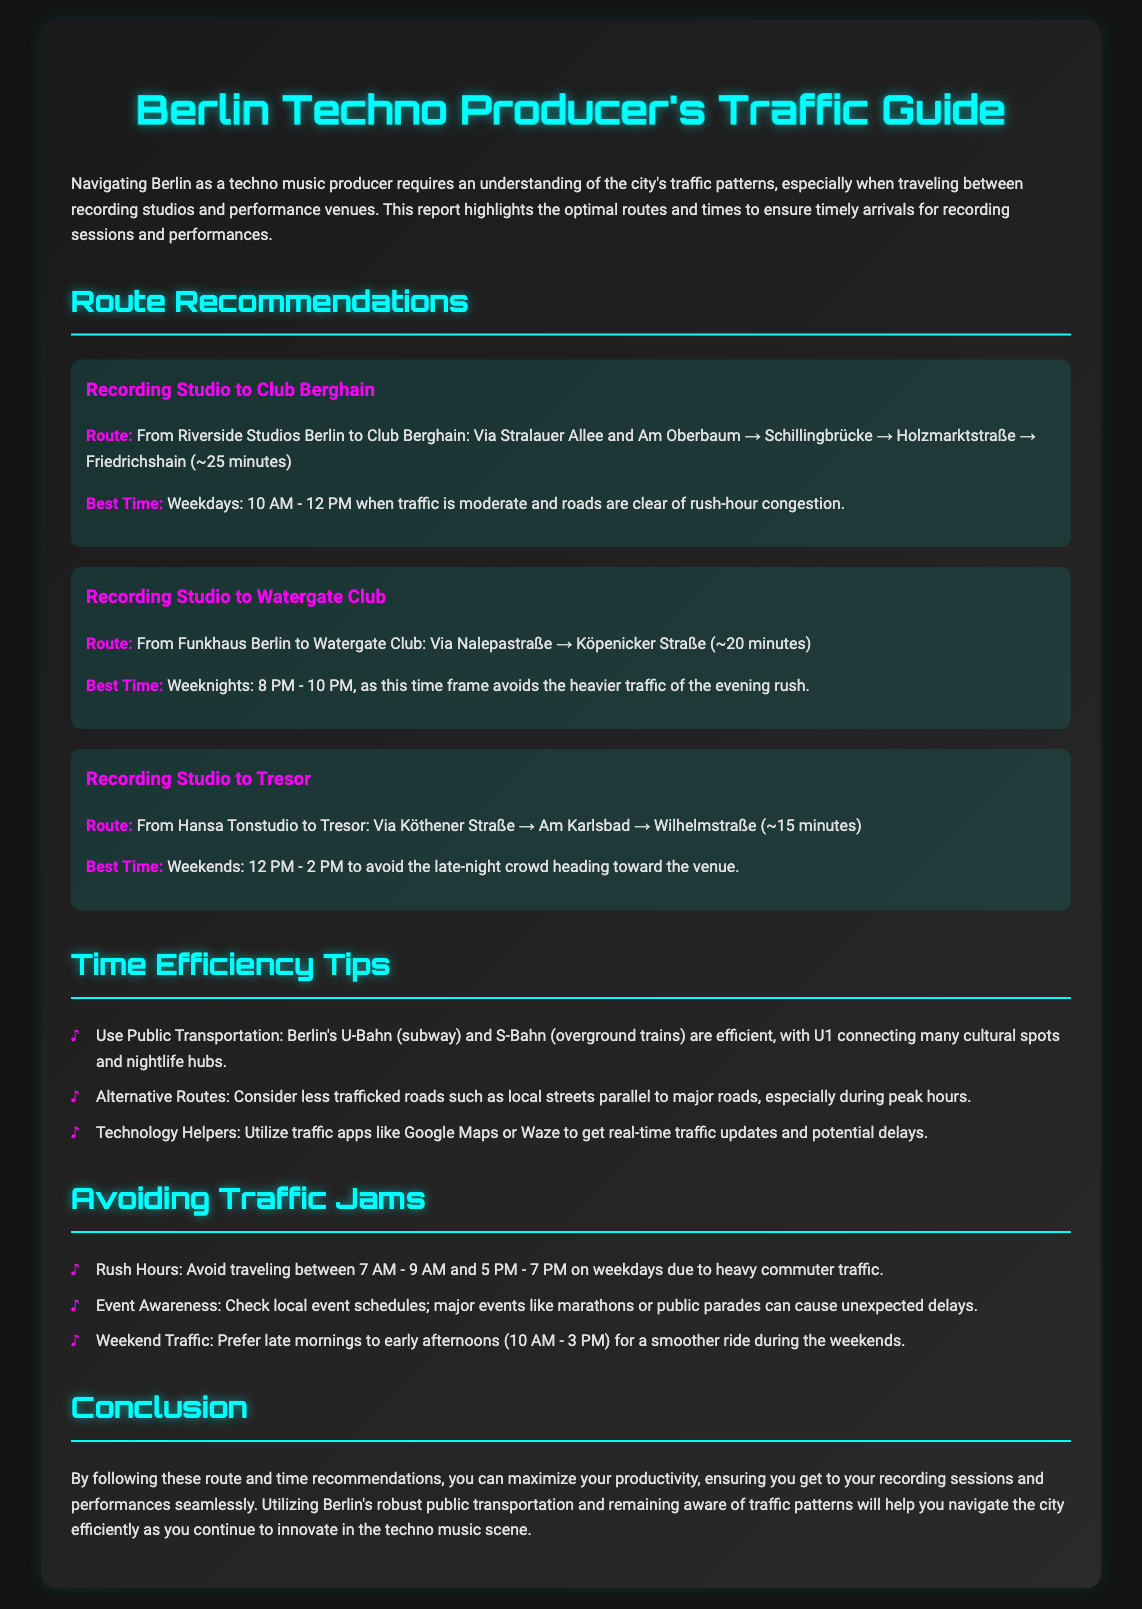What is the best time to travel from Riverside Studios to Club Berghain? The document states that the best time is weekdays from 10 AM to 12 PM when traffic is moderate.
Answer: Weekdays: 10 AM - 12 PM What route is recommended from Funkhaus Berlin to Watergate Club? The route recommended is via Nalepastraße and Köpenicker Straße.
Answer: Via Nalepastraße → Köpenicker Straße How long does it take to get from Hansa Tonstudio to Tresor? The document specifies that the travel time is approximately 15 minutes.
Answer: ~15 minutes What is a time efficiency tip mentioned in the document? The document mentions using public transportation, such as U-Bahn and S-Bahn, as an efficiency tip.
Answer: Use Public Transportation During which hours should you avoid traveling on weekdays? The document specifies avoiding weekdays between 7 AM to 9 AM and 5 PM to 7 PM due to heavy commuter traffic.
Answer: 7 AM - 9 AM and 5 PM - 7 PM What is the route from Riverside Studios to Club Berghain? The document outlines the route as Stralauer Allee and Am Oberbaum → Schillingbrücke → Holzmarktstraße → Friedrichshain.
Answer: Via Stralauer Allee and Am Oberbaum → Schillingbrücke → Holzmarktstraße → Friedrichshain When is the best time to travel to Tresor? The best time to travel to Tresor is weekends from 12 PM to 2 PM.
Answer: Weekends: 12 PM - 2 PM What should you check to avoid unexpected delays while traveling? The document recommends checking local event schedules to avoid traffic due to events like marathons or public parades.
Answer: Local event schedules 